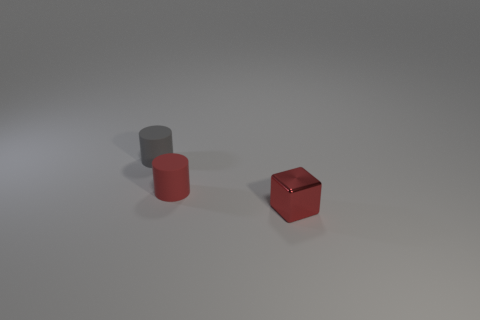Add 2 gray things. How many objects exist? 5 Subtract all cubes. How many objects are left? 2 Subtract 1 cubes. How many cubes are left? 0 Add 1 tiny gray matte cylinders. How many tiny gray matte cylinders are left? 2 Add 1 big brown matte spheres. How many big brown matte spheres exist? 1 Subtract 0 blue balls. How many objects are left? 3 Subtract all cyan cylinders. Subtract all green cubes. How many cylinders are left? 2 Subtract all yellow cylinders. How many brown cubes are left? 0 Subtract all red matte cylinders. Subtract all tiny gray matte blocks. How many objects are left? 2 